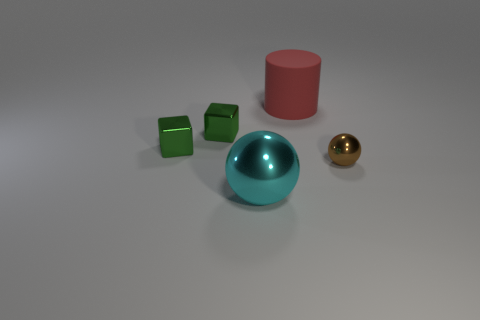Is the brown ball made of the same material as the large thing that is on the left side of the red cylinder?
Ensure brevity in your answer.  Yes. What is the shape of the large thing behind the tiny metal object that is to the right of the big rubber cylinder?
Ensure brevity in your answer.  Cylinder. There is a thing that is both to the right of the large metal thing and in front of the red thing; what is its shape?
Offer a very short reply. Sphere. What number of things are either large gray shiny cubes or large cyan metal balls that are in front of the brown object?
Offer a very short reply. 1. Is there any other thing that is made of the same material as the red cylinder?
Give a very brief answer. No. The object that is in front of the matte object and right of the large cyan metallic thing is made of what material?
Provide a succinct answer. Metal. What number of other large red objects have the same shape as the red matte thing?
Your answer should be very brief. 0. What color is the large object left of the big rubber object that is to the right of the cyan shiny object?
Make the answer very short. Cyan. Is the number of tiny brown metallic objects that are to the left of the tiny brown shiny sphere the same as the number of spheres?
Ensure brevity in your answer.  No. Are there any metal balls that have the same size as the brown object?
Make the answer very short. No. 